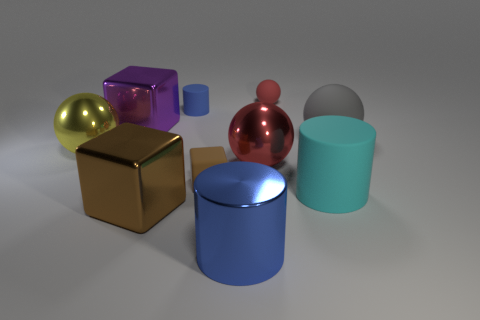The large blue thing is what shape?
Your answer should be compact. Cylinder. What is the color of the cylinder that is left of the small red sphere and in front of the tiny rubber cylinder?
Provide a short and direct response. Blue. What is the large brown thing made of?
Keep it short and to the point. Metal. What is the shape of the red thing that is behind the large red object?
Your response must be concise. Sphere. What is the color of the matte sphere that is the same size as the blue metallic cylinder?
Offer a terse response. Gray. Is the blue cylinder behind the large blue metallic cylinder made of the same material as the yellow object?
Offer a terse response. No. There is a ball that is both right of the purple metallic block and in front of the gray object; how big is it?
Your answer should be compact. Large. There is a brown block that is in front of the brown rubber cube; how big is it?
Provide a short and direct response. Large. What is the shape of the object that is the same color as the metal cylinder?
Ensure brevity in your answer.  Cylinder. What is the shape of the large thing to the right of the large cylinder that is to the right of the blue cylinder in front of the big cyan matte cylinder?
Keep it short and to the point. Sphere. 